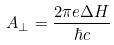Convert formula to latex. <formula><loc_0><loc_0><loc_500><loc_500>A _ { \perp } = \frac { 2 \pi e \Delta H } { \hbar { c } }</formula> 